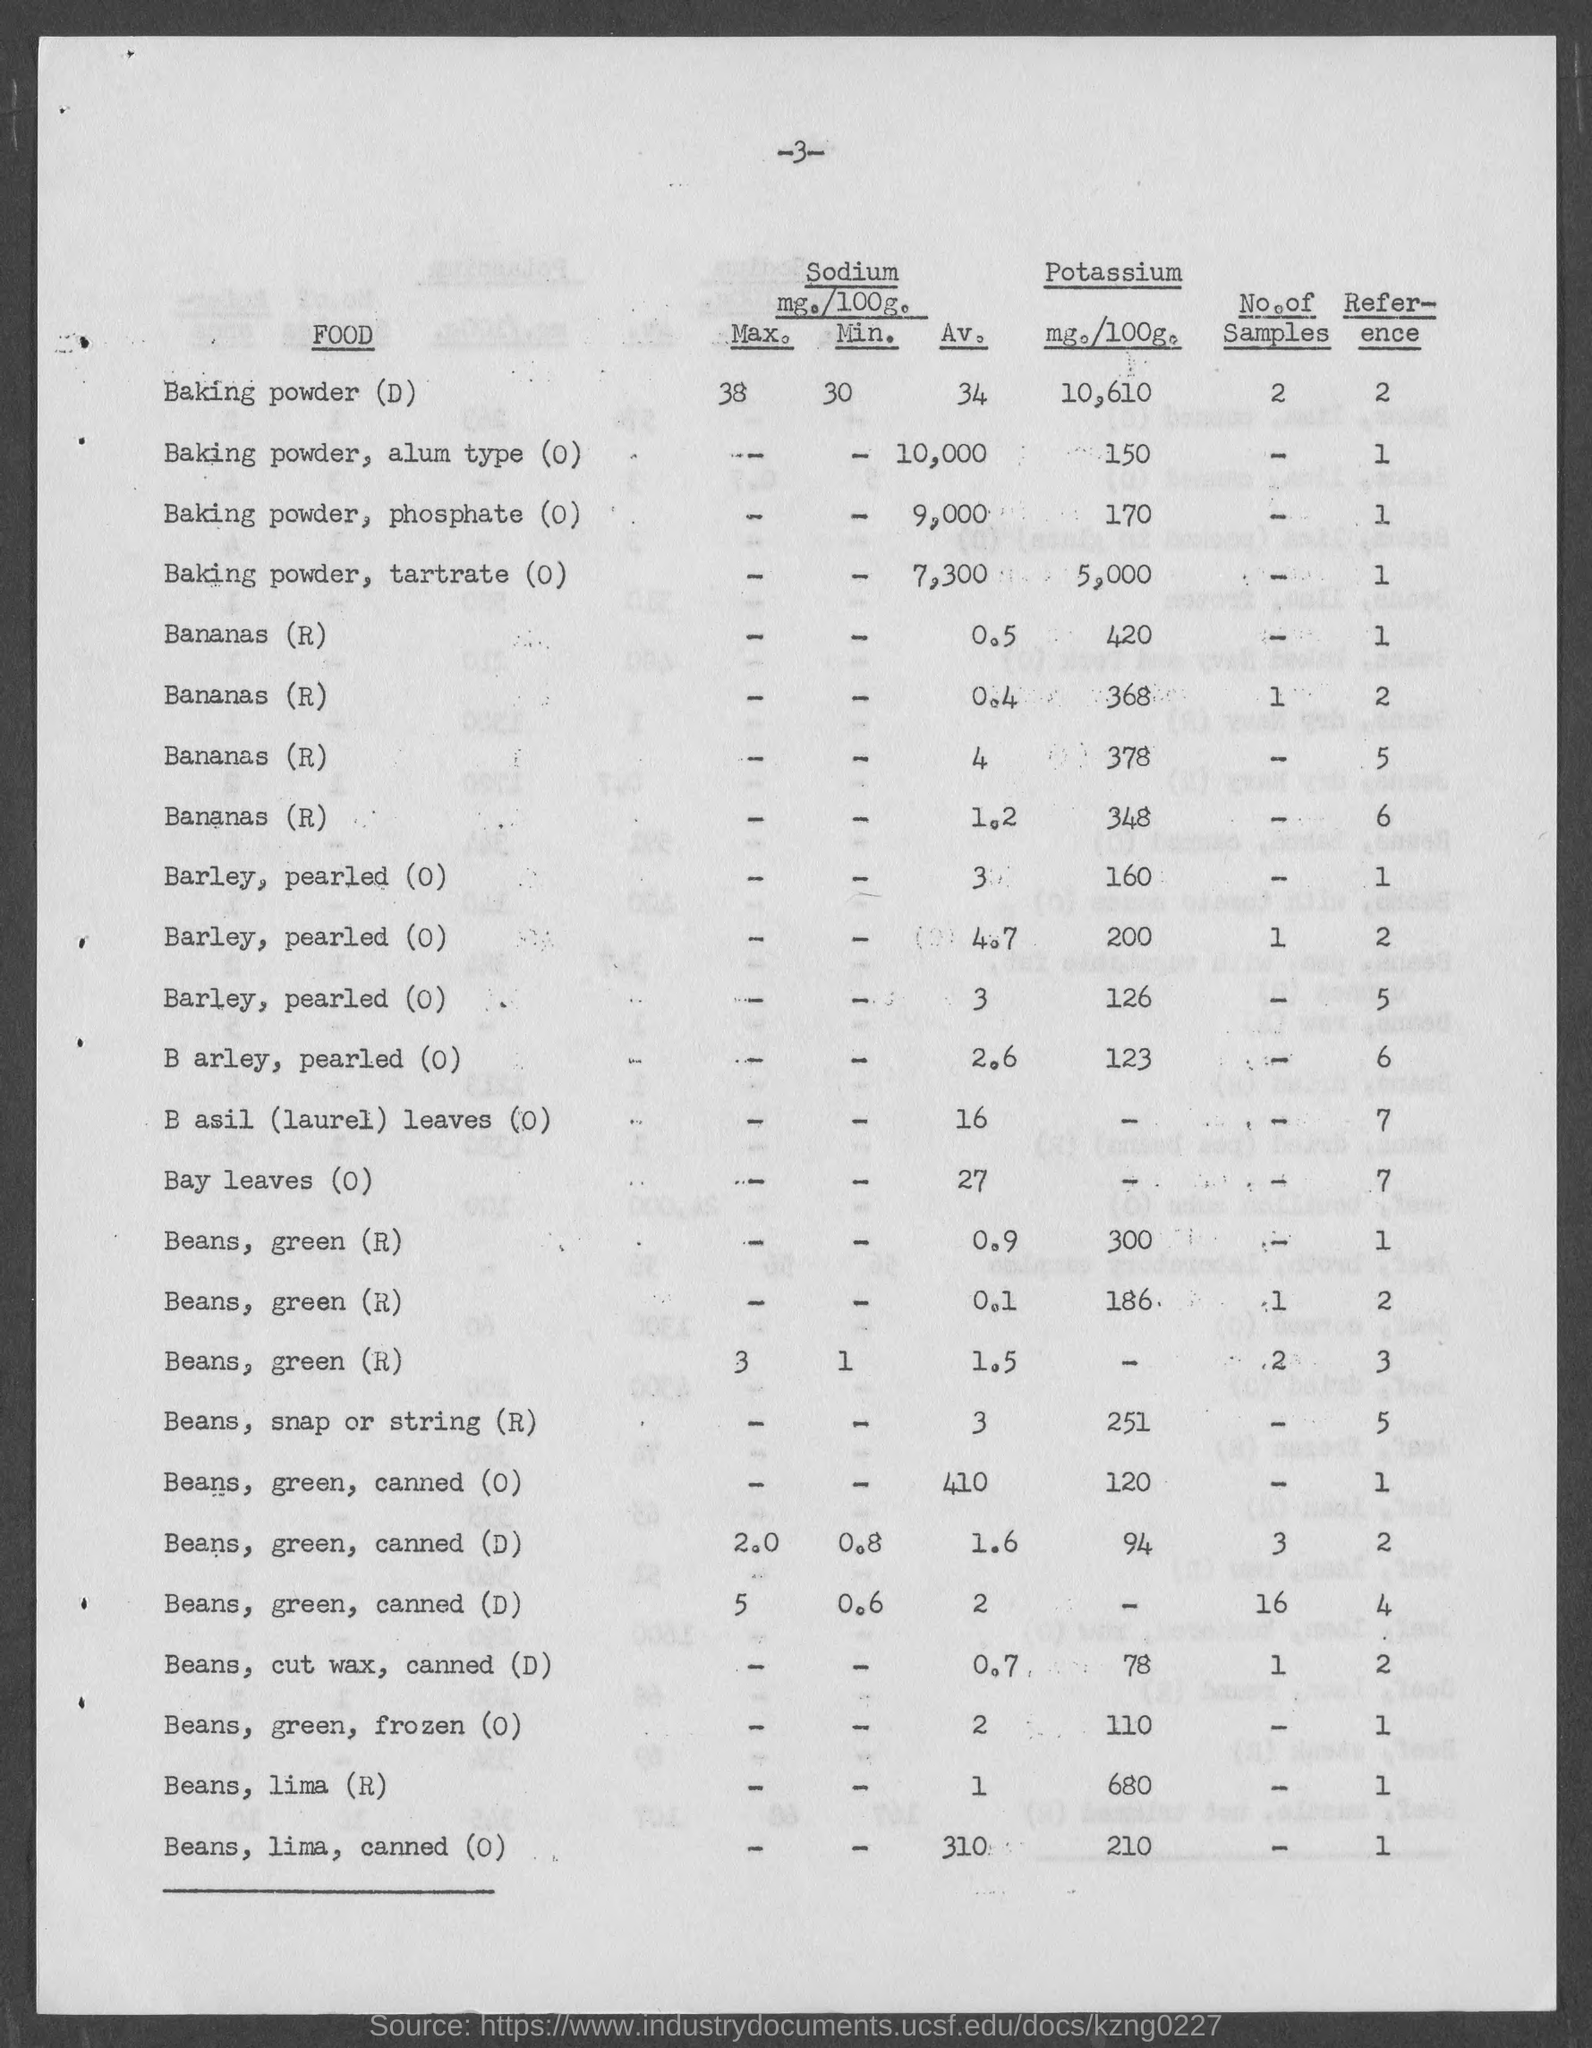What is the number at top of the page ?
Offer a terse response. -3-. What is the amount of potassium mg./100g. of baking powder (d)?
Keep it short and to the point. 10,610. What is the amount of potassium mg./100g. of baking powder, alum type (o)?
Your answer should be compact. 150. What is the amount of potassium mg./100g. of baking powder, phosphate(o)?
Give a very brief answer. 170. What is the amount of potassium mg./100g.  of baking powder, tartrate(o)?
Your response must be concise. 5000. What is the amount of potassium mg./100g. of beans,snap or string (r)?
Make the answer very short. 251. What is the amount of potassium mg./100g. of beans,cut wax, canned(d)?
Offer a very short reply. 78. What is the amount of potassium mg./100g. of beans, green, frozen (o)?
Your answer should be compact. 110. What is the amount of potassium mg./100g. of beans, lima (r)?
Offer a very short reply. 680. What is the amount of potassium mg./100g. of beans, lima, canned (o)?
Give a very brief answer. 210. 